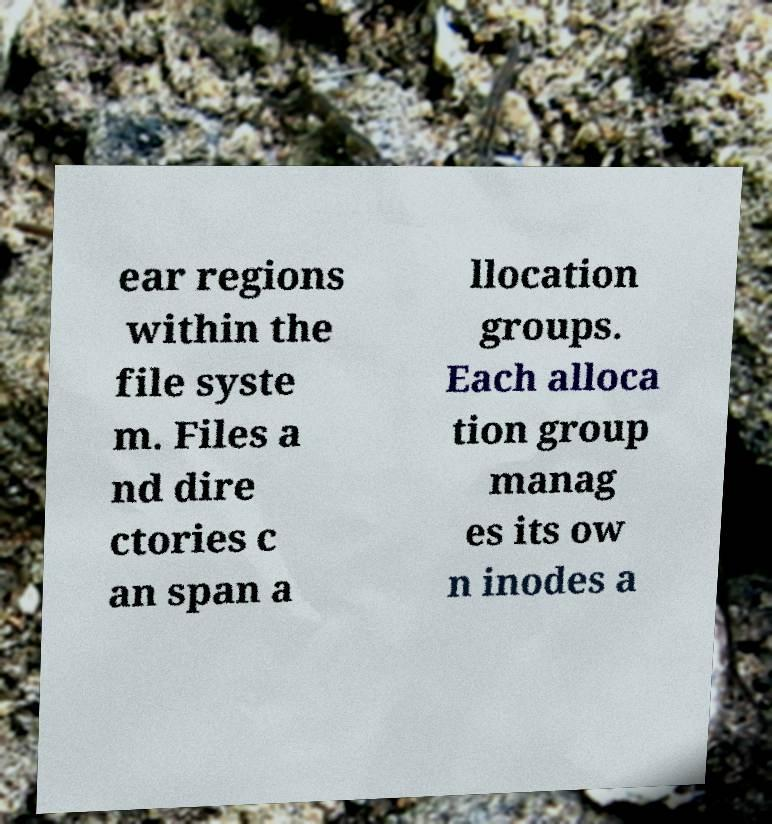Please identify and transcribe the text found in this image. ear regions within the file syste m. Files a nd dire ctories c an span a llocation groups. Each alloca tion group manag es its ow n inodes a 